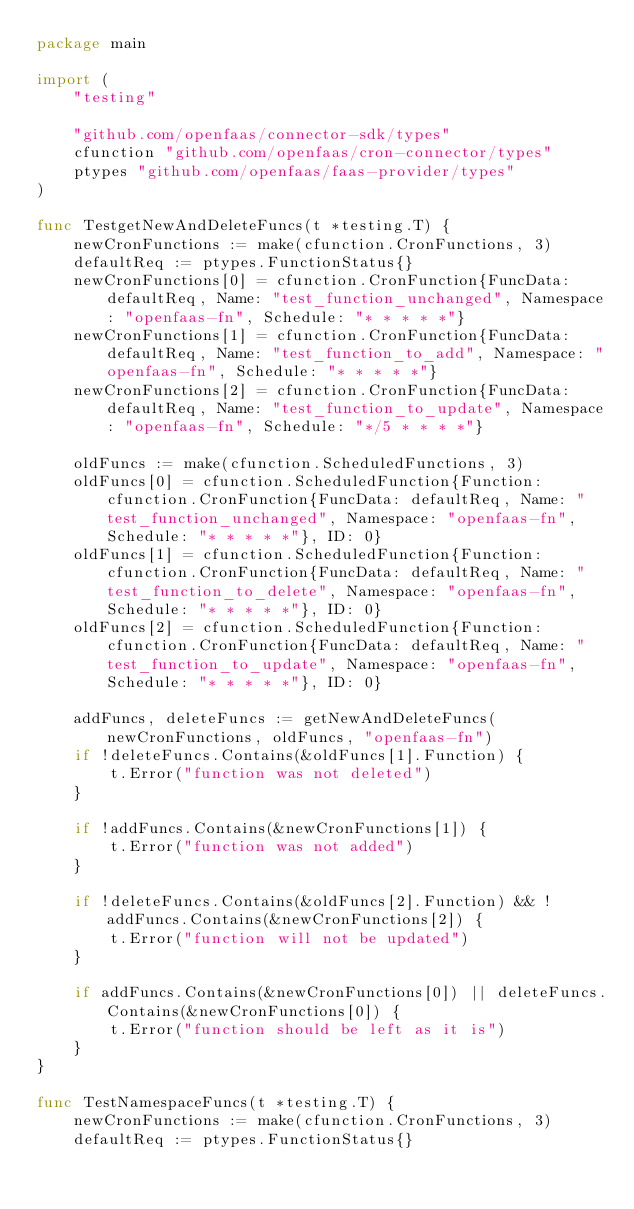<code> <loc_0><loc_0><loc_500><loc_500><_Go_>package main

import (
	"testing"

	"github.com/openfaas/connector-sdk/types"
	cfunction "github.com/openfaas/cron-connector/types"
	ptypes "github.com/openfaas/faas-provider/types"
)

func TestgetNewAndDeleteFuncs(t *testing.T) {
	newCronFunctions := make(cfunction.CronFunctions, 3)
	defaultReq := ptypes.FunctionStatus{}
	newCronFunctions[0] = cfunction.CronFunction{FuncData: defaultReq, Name: "test_function_unchanged", Namespace: "openfaas-fn", Schedule: "* * * * *"}
	newCronFunctions[1] = cfunction.CronFunction{FuncData: defaultReq, Name: "test_function_to_add", Namespace: "openfaas-fn", Schedule: "* * * * *"}
	newCronFunctions[2] = cfunction.CronFunction{FuncData: defaultReq, Name: "test_function_to_update", Namespace: "openfaas-fn", Schedule: "*/5 * * * *"}

	oldFuncs := make(cfunction.ScheduledFunctions, 3)
	oldFuncs[0] = cfunction.ScheduledFunction{Function: cfunction.CronFunction{FuncData: defaultReq, Name: "test_function_unchanged", Namespace: "openfaas-fn", Schedule: "* * * * *"}, ID: 0}
	oldFuncs[1] = cfunction.ScheduledFunction{Function: cfunction.CronFunction{FuncData: defaultReq, Name: "test_function_to_delete", Namespace: "openfaas-fn", Schedule: "* * * * *"}, ID: 0}
	oldFuncs[2] = cfunction.ScheduledFunction{Function: cfunction.CronFunction{FuncData: defaultReq, Name: "test_function_to_update", Namespace: "openfaas-fn", Schedule: "* * * * *"}, ID: 0}

	addFuncs, deleteFuncs := getNewAndDeleteFuncs(newCronFunctions, oldFuncs, "openfaas-fn")
	if !deleteFuncs.Contains(&oldFuncs[1].Function) {
		t.Error("function was not deleted")
	}

	if !addFuncs.Contains(&newCronFunctions[1]) {
		t.Error("function was not added")
	}

	if !deleteFuncs.Contains(&oldFuncs[2].Function) && !addFuncs.Contains(&newCronFunctions[2]) {
		t.Error("function will not be updated")
	}

	if addFuncs.Contains(&newCronFunctions[0]) || deleteFuncs.Contains(&newCronFunctions[0]) {
		t.Error("function should be left as it is")
	}
}

func TestNamespaceFuncs(t *testing.T) {
	newCronFunctions := make(cfunction.CronFunctions, 3)
	defaultReq := ptypes.FunctionStatus{}</code> 